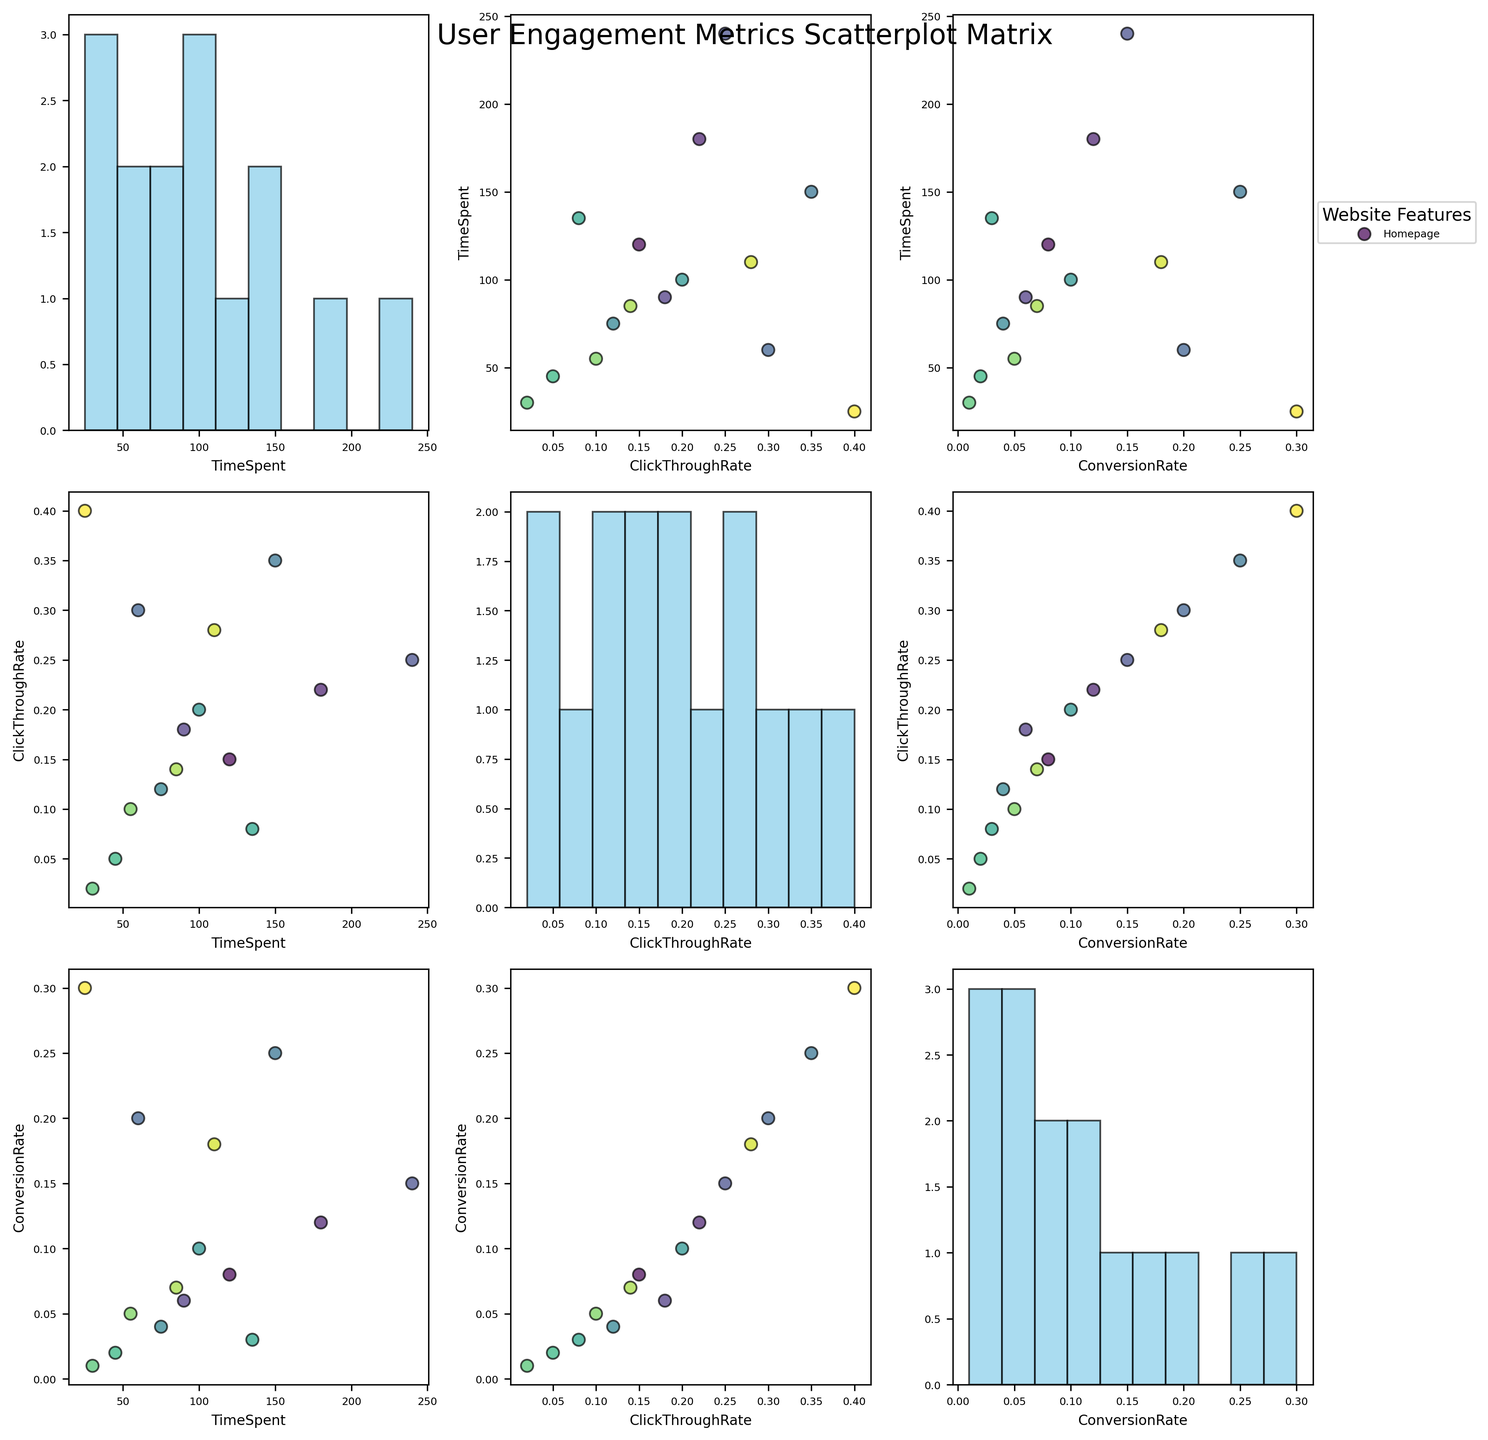What is the title of the figure? The title of the figure is shown at the top of the plot, it reads "User Engagement Metrics Scatterplot Matrix".
Answer: User Engagement Metrics Scatterplot Matrix What three features are being compared in the scatterplot matrix? The three features being compared are listed as the column and row labels. They are "TimeSpent", "ClickThroughRate", and "ConversionRate".
Answer: TimeSpent, ClickThroughRate, ConversionRate How many website features are represented in the scatterplot matrix? Each dot in the scatterplots corresponds to a different website feature, and there are 15 data points (or dots) present.
Answer: 15 Which feature generally has the highest click-through rates? By looking at the scatterplots involving the "ClickThroughRate" feature, it can be observed that most of the highest values are concentrated around the "Checkout" feature, particularly when comparing to other features.
Answer: Checkout Is there a notable correlation between TimeSpent and ConversionRate? By observing the scatterplot where TimeSpent is on the y-axis and ConversionRate is on the x-axis, there appears to be a positive trend, meaning higher TimeSpent tends to be associated with higher ConversionRate.
Answer: Yes Which feature has the highest ConversionRate value? By looking at the histogram plotted for "ConversionRate", the bar indicating the highest value corresponds to "EmailSignup" with a value of 0.30.
Answer: EmailSignup Which features have the smallest values in all three metrics? Observing the scatterplot and histograms, the feature with the lowest values across all metrics is "AccountSettings". It has the lowest TimeSpent, ClickThroughRate, and ConversionRate.
Answer: AccountSettings Do the ProductDetails and Checkout features show similar trends in user engagement metrics? By comparing the data points of ProductDetails and Checkout in the scatterplots, it is evident that both features show high values across all metrics, indicating similar trends.
Answer: Yes Which two features seem to have negative or no correlation between TimeSpent and ClickThroughRate? By checking the scatterplot where TimeSpent is on the y-axis and ClickThroughRate is on the x-axis, the "ShoppingCart" and the "LiveChat" features exhibit a negative or no correlation. Higher ClickThroughRate does not correspond to higher TimeSpent for these features.
Answer: ShoppingCart, LiveChat 